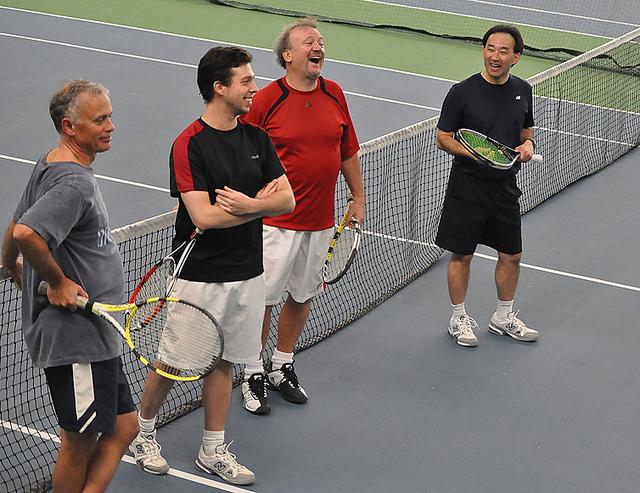How many men have tennis rackets?
Write a very short answer. 4. How many men are wearing white shorts?
Write a very short answer. 2. What color is the court?
Concise answer only. Gray. 